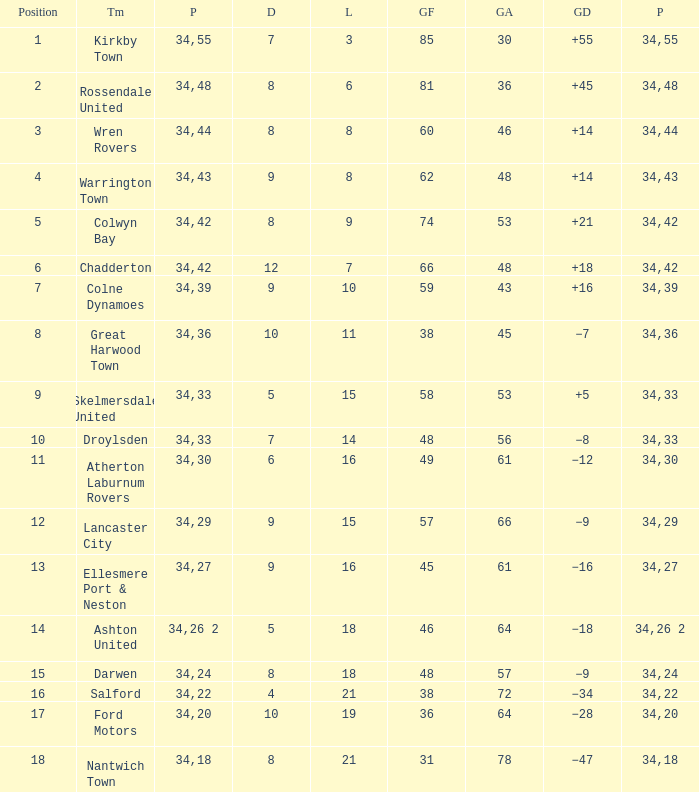What is the total number of positions when there are more than 48 goals against, 1 of 29 points are played, and less than 34 games have been played? 0.0. 